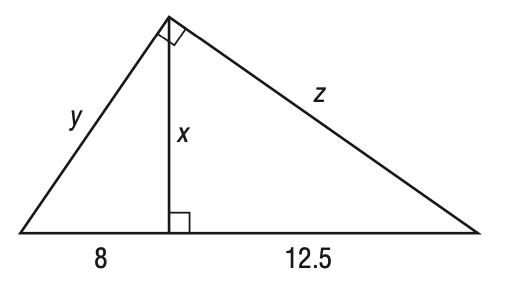Answer the mathemtical geometry problem and directly provide the correct option letter.
Question: Refer to the triangle shown below. Find x to the nearest tenth.
Choices: A: 8 B: 10 C: 12.5 D: 15 B 